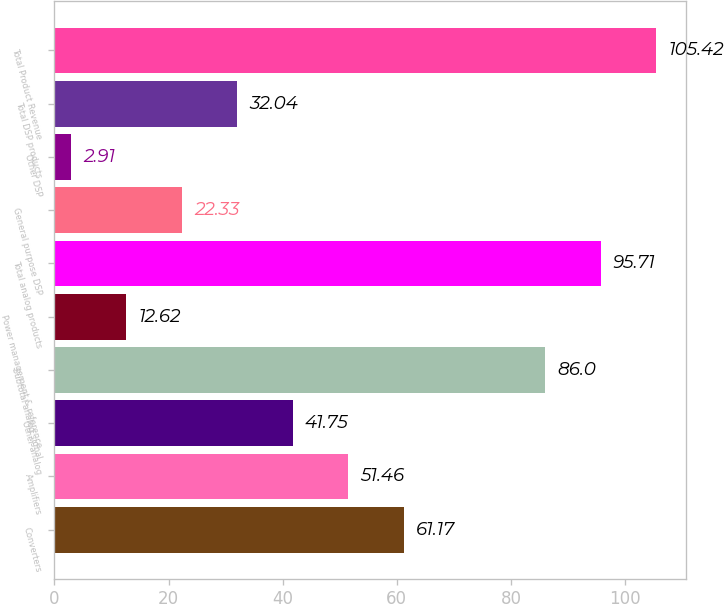Convert chart. <chart><loc_0><loc_0><loc_500><loc_500><bar_chart><fcel>Converters<fcel>Amplifiers<fcel>Other analog<fcel>Subtotal analog signal<fcel>Power management & reference<fcel>Total analog products<fcel>General purpose DSP<fcel>Other DSP<fcel>Total DSP products<fcel>Total Product Revenue<nl><fcel>61.17<fcel>51.46<fcel>41.75<fcel>86<fcel>12.62<fcel>95.71<fcel>22.33<fcel>2.91<fcel>32.04<fcel>105.42<nl></chart> 